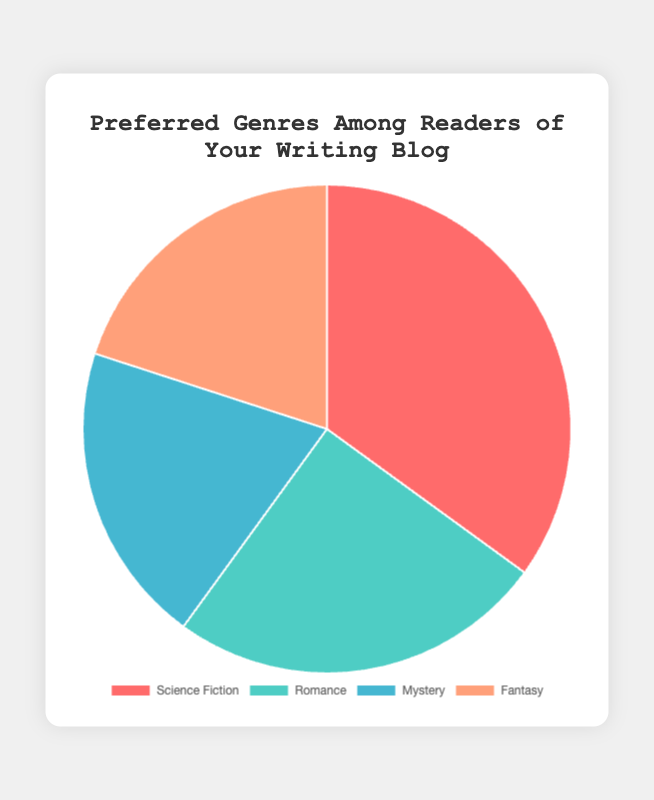What percentage of your readers prefer Romance over Fantasy? By looking at the pie chart, Romance is 25% and Fantasy is 20%. Therefore, 25% of readers prefer Romance over Fantasy.
Answer: 25% How much more popular is Science Fiction compared to Mystery? Science Fiction is 35% and Mystery is 20%. The difference is 35% - 20% = 15%.
Answer: 15% Which genre is the least popular among the readers? According to the pie chart, both Mystery and Fantasy are equal at 20%, which are the lowest.
Answer: Mystery and Fantasy What is the average percentage of readers across all genres? Sum the percentages (35 + 25 + 20 + 20 = 100) and then divide by the number of genres (4). The average is 100 / 4 = 25%.
Answer: 25% How much more popular are the two most popular genres together compared to the two least popular genres together? The two most popular genres are Science Fiction (35%) and Romance (25%). The two least popular genres are Mystery (20%) and Fantasy (20%). Sum of the two most popular genres is 35 + 25 = 60, and the sum of the two least popular is 20 + 20 = 40. The difference is 60 - 40 = 20%.
Answer: 20% What fraction of your readers prefer genres other than Science Fiction? Science Fiction is 35%, so the other genres combined are 100% - 35% = 65%.
Answer: 65% Which genre segment is represented by the color blue in the pie chart? According to the chart’s color key, the blue segment corresponds to the genre Mystery.
Answer: Mystery If 1000 readers participated in this poll, how many of them prefer Fantasy? Fantasy is preferred by 20% of readers. If 1000 readers participated, then 20% of 1000 is (20/100)*1000 = 200 readers.
Answer: 200 What is the combined percentage of readers who prefer either Mystery or Fantasy? Both genres Mystery and Fantasy are 20% each. Combined, they make 20% + 20% = 40%.
Answer: 40% Is Romance more popular than either Mystery or Fantasy? Romance has 25%, while both Mystery and Fantasy each have 20%, so Romance is more popular than either of these genres.
Answer: Yes 